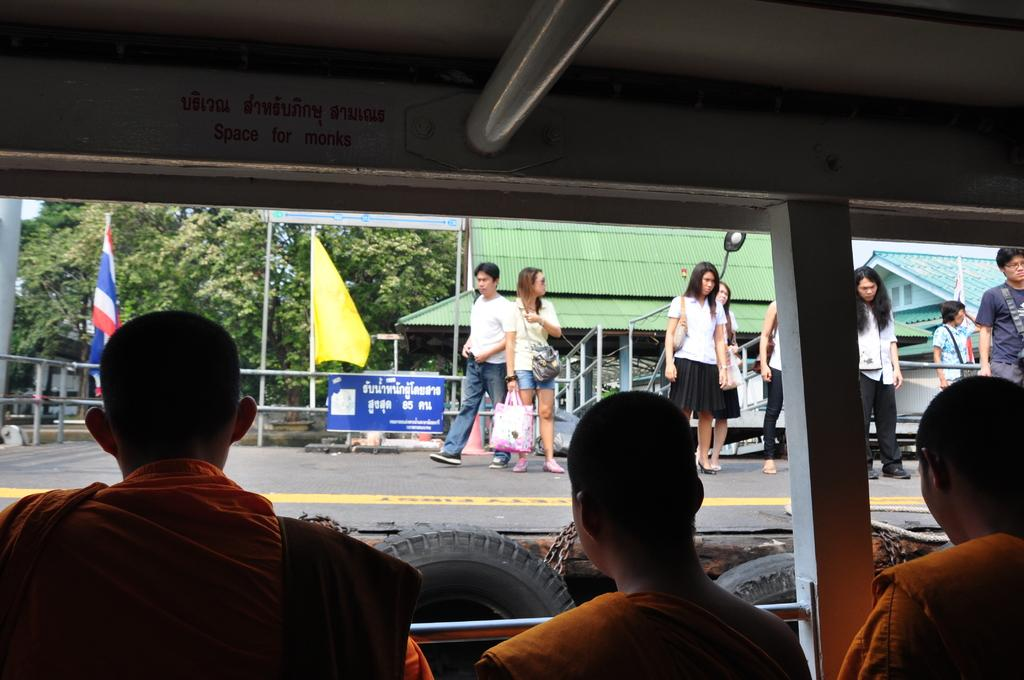How many people are in the boat in the image? There are 3 people sitting in the boat in the image. What are the people in front of the boat doing? There is a group of people standing in front of the boat. What can be seen in the background of the image? Many trees are visible in the image. What color is the flag in the image? There is a yellow flag in the image. What type of pain is the boat experiencing in the image? There is no indication of pain in the image, as it features people in a boat and a group of people standing in front of it. 